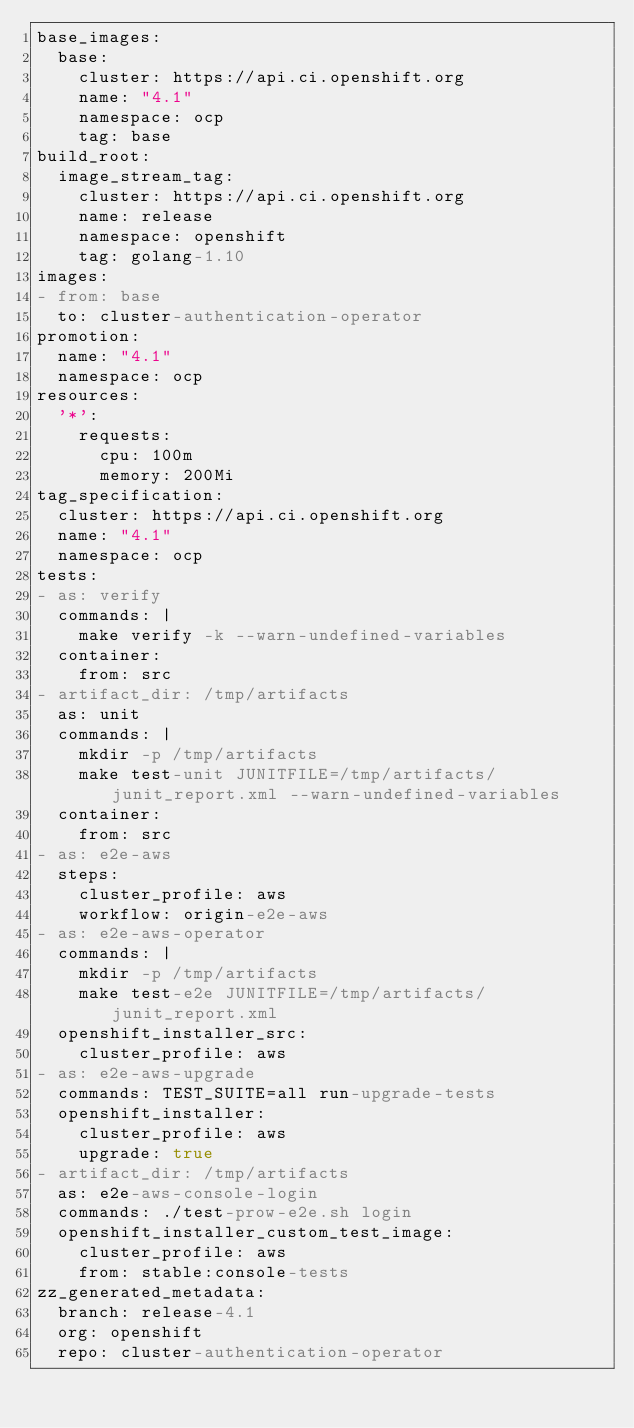Convert code to text. <code><loc_0><loc_0><loc_500><loc_500><_YAML_>base_images:
  base:
    cluster: https://api.ci.openshift.org
    name: "4.1"
    namespace: ocp
    tag: base
build_root:
  image_stream_tag:
    cluster: https://api.ci.openshift.org
    name: release
    namespace: openshift
    tag: golang-1.10
images:
- from: base
  to: cluster-authentication-operator
promotion:
  name: "4.1"
  namespace: ocp
resources:
  '*':
    requests:
      cpu: 100m
      memory: 200Mi
tag_specification:
  cluster: https://api.ci.openshift.org
  name: "4.1"
  namespace: ocp
tests:
- as: verify
  commands: |
    make verify -k --warn-undefined-variables
  container:
    from: src
- artifact_dir: /tmp/artifacts
  as: unit
  commands: |
    mkdir -p /tmp/artifacts
    make test-unit JUNITFILE=/tmp/artifacts/junit_report.xml --warn-undefined-variables
  container:
    from: src
- as: e2e-aws
  steps:
    cluster_profile: aws
    workflow: origin-e2e-aws
- as: e2e-aws-operator
  commands: |
    mkdir -p /tmp/artifacts
    make test-e2e JUNITFILE=/tmp/artifacts/junit_report.xml
  openshift_installer_src:
    cluster_profile: aws
- as: e2e-aws-upgrade
  commands: TEST_SUITE=all run-upgrade-tests
  openshift_installer:
    cluster_profile: aws
    upgrade: true
- artifact_dir: /tmp/artifacts
  as: e2e-aws-console-login
  commands: ./test-prow-e2e.sh login
  openshift_installer_custom_test_image:
    cluster_profile: aws
    from: stable:console-tests
zz_generated_metadata:
  branch: release-4.1
  org: openshift
  repo: cluster-authentication-operator
</code> 